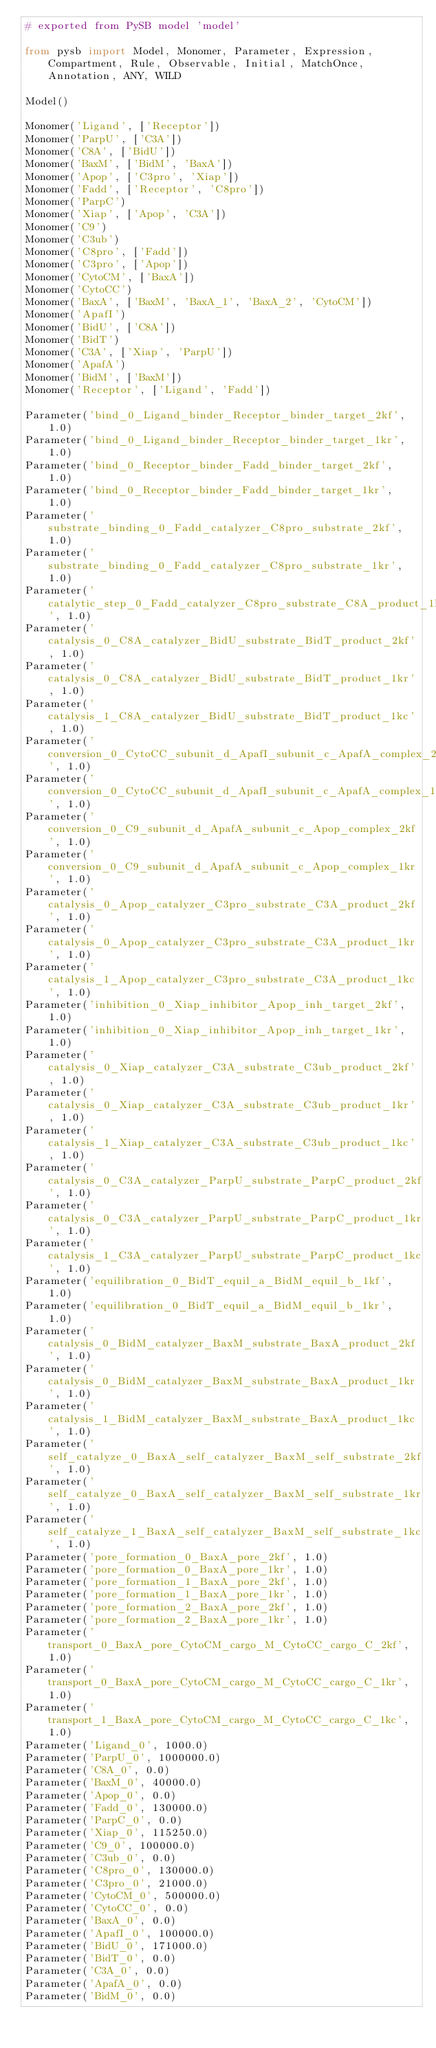<code> <loc_0><loc_0><loc_500><loc_500><_Python_># exported from PySB model 'model'

from pysb import Model, Monomer, Parameter, Expression, Compartment, Rule, Observable, Initial, MatchOnce, Annotation, ANY, WILD

Model()

Monomer('Ligand', ['Receptor'])
Monomer('ParpU', ['C3A'])
Monomer('C8A', ['BidU'])
Monomer('BaxM', ['BidM', 'BaxA'])
Monomer('Apop', ['C3pro', 'Xiap'])
Monomer('Fadd', ['Receptor', 'C8pro'])
Monomer('ParpC')
Monomer('Xiap', ['Apop', 'C3A'])
Monomer('C9')
Monomer('C3ub')
Monomer('C8pro', ['Fadd'])
Monomer('C3pro', ['Apop'])
Monomer('CytoCM', ['BaxA'])
Monomer('CytoCC')
Monomer('BaxA', ['BaxM', 'BaxA_1', 'BaxA_2', 'CytoCM'])
Monomer('ApafI')
Monomer('BidU', ['C8A'])
Monomer('BidT')
Monomer('C3A', ['Xiap', 'ParpU'])
Monomer('ApafA')
Monomer('BidM', ['BaxM'])
Monomer('Receptor', ['Ligand', 'Fadd'])

Parameter('bind_0_Ligand_binder_Receptor_binder_target_2kf', 1.0)
Parameter('bind_0_Ligand_binder_Receptor_binder_target_1kr', 1.0)
Parameter('bind_0_Receptor_binder_Fadd_binder_target_2kf', 1.0)
Parameter('bind_0_Receptor_binder_Fadd_binder_target_1kr', 1.0)
Parameter('substrate_binding_0_Fadd_catalyzer_C8pro_substrate_2kf', 1.0)
Parameter('substrate_binding_0_Fadd_catalyzer_C8pro_substrate_1kr', 1.0)
Parameter('catalytic_step_0_Fadd_catalyzer_C8pro_substrate_C8A_product_1kc', 1.0)
Parameter('catalysis_0_C8A_catalyzer_BidU_substrate_BidT_product_2kf', 1.0)
Parameter('catalysis_0_C8A_catalyzer_BidU_substrate_BidT_product_1kr', 1.0)
Parameter('catalysis_1_C8A_catalyzer_BidU_substrate_BidT_product_1kc', 1.0)
Parameter('conversion_0_CytoCC_subunit_d_ApafI_subunit_c_ApafA_complex_2kf', 1.0)
Parameter('conversion_0_CytoCC_subunit_d_ApafI_subunit_c_ApafA_complex_1kr', 1.0)
Parameter('conversion_0_C9_subunit_d_ApafA_subunit_c_Apop_complex_2kf', 1.0)
Parameter('conversion_0_C9_subunit_d_ApafA_subunit_c_Apop_complex_1kr', 1.0)
Parameter('catalysis_0_Apop_catalyzer_C3pro_substrate_C3A_product_2kf', 1.0)
Parameter('catalysis_0_Apop_catalyzer_C3pro_substrate_C3A_product_1kr', 1.0)
Parameter('catalysis_1_Apop_catalyzer_C3pro_substrate_C3A_product_1kc', 1.0)
Parameter('inhibition_0_Xiap_inhibitor_Apop_inh_target_2kf', 1.0)
Parameter('inhibition_0_Xiap_inhibitor_Apop_inh_target_1kr', 1.0)
Parameter('catalysis_0_Xiap_catalyzer_C3A_substrate_C3ub_product_2kf', 1.0)
Parameter('catalysis_0_Xiap_catalyzer_C3A_substrate_C3ub_product_1kr', 1.0)
Parameter('catalysis_1_Xiap_catalyzer_C3A_substrate_C3ub_product_1kc', 1.0)
Parameter('catalysis_0_C3A_catalyzer_ParpU_substrate_ParpC_product_2kf', 1.0)
Parameter('catalysis_0_C3A_catalyzer_ParpU_substrate_ParpC_product_1kr', 1.0)
Parameter('catalysis_1_C3A_catalyzer_ParpU_substrate_ParpC_product_1kc', 1.0)
Parameter('equilibration_0_BidT_equil_a_BidM_equil_b_1kf', 1.0)
Parameter('equilibration_0_BidT_equil_a_BidM_equil_b_1kr', 1.0)
Parameter('catalysis_0_BidM_catalyzer_BaxM_substrate_BaxA_product_2kf', 1.0)
Parameter('catalysis_0_BidM_catalyzer_BaxM_substrate_BaxA_product_1kr', 1.0)
Parameter('catalysis_1_BidM_catalyzer_BaxM_substrate_BaxA_product_1kc', 1.0)
Parameter('self_catalyze_0_BaxA_self_catalyzer_BaxM_self_substrate_2kf', 1.0)
Parameter('self_catalyze_0_BaxA_self_catalyzer_BaxM_self_substrate_1kr', 1.0)
Parameter('self_catalyze_1_BaxA_self_catalyzer_BaxM_self_substrate_1kc', 1.0)
Parameter('pore_formation_0_BaxA_pore_2kf', 1.0)
Parameter('pore_formation_0_BaxA_pore_1kr', 1.0)
Parameter('pore_formation_1_BaxA_pore_2kf', 1.0)
Parameter('pore_formation_1_BaxA_pore_1kr', 1.0)
Parameter('pore_formation_2_BaxA_pore_2kf', 1.0)
Parameter('pore_formation_2_BaxA_pore_1kr', 1.0)
Parameter('transport_0_BaxA_pore_CytoCM_cargo_M_CytoCC_cargo_C_2kf', 1.0)
Parameter('transport_0_BaxA_pore_CytoCM_cargo_M_CytoCC_cargo_C_1kr', 1.0)
Parameter('transport_1_BaxA_pore_CytoCM_cargo_M_CytoCC_cargo_C_1kc', 1.0)
Parameter('Ligand_0', 1000.0)
Parameter('ParpU_0', 1000000.0)
Parameter('C8A_0', 0.0)
Parameter('BaxM_0', 40000.0)
Parameter('Apop_0', 0.0)
Parameter('Fadd_0', 130000.0)
Parameter('ParpC_0', 0.0)
Parameter('Xiap_0', 115250.0)
Parameter('C9_0', 100000.0)
Parameter('C3ub_0', 0.0)
Parameter('C8pro_0', 130000.0)
Parameter('C3pro_0', 21000.0)
Parameter('CytoCM_0', 500000.0)
Parameter('CytoCC_0', 0.0)
Parameter('BaxA_0', 0.0)
Parameter('ApafI_0', 100000.0)
Parameter('BidU_0', 171000.0)
Parameter('BidT_0', 0.0)
Parameter('C3A_0', 0.0)
Parameter('ApafA_0', 0.0)
Parameter('BidM_0', 0.0)</code> 